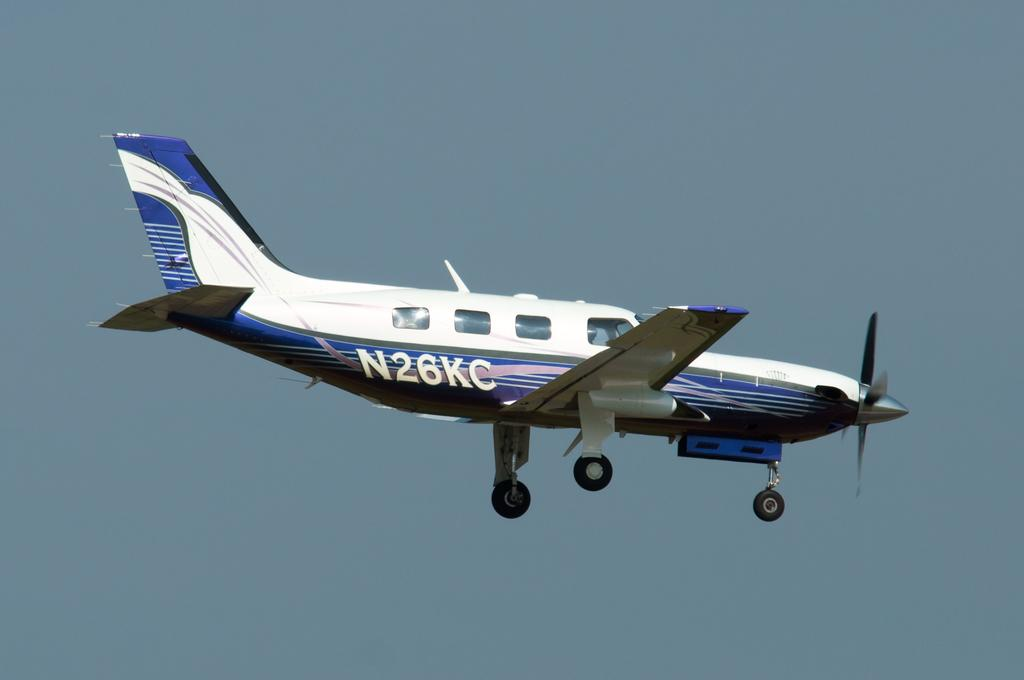<image>
Write a terse but informative summary of the picture. A blue and white airplane in mid flight with the text N26KC on the bottom back half of it. 